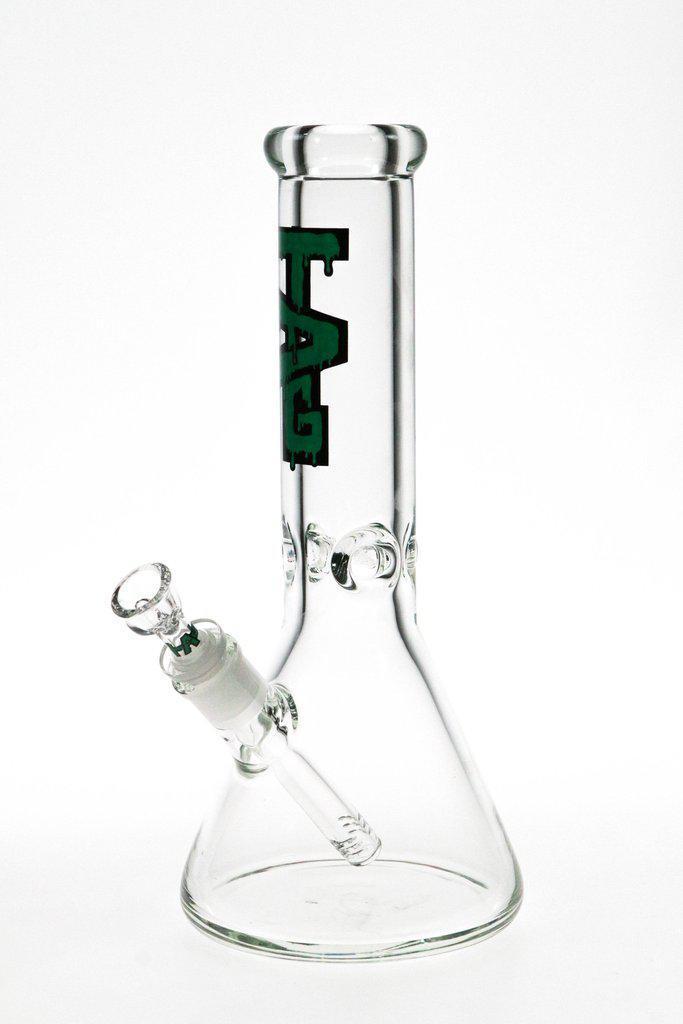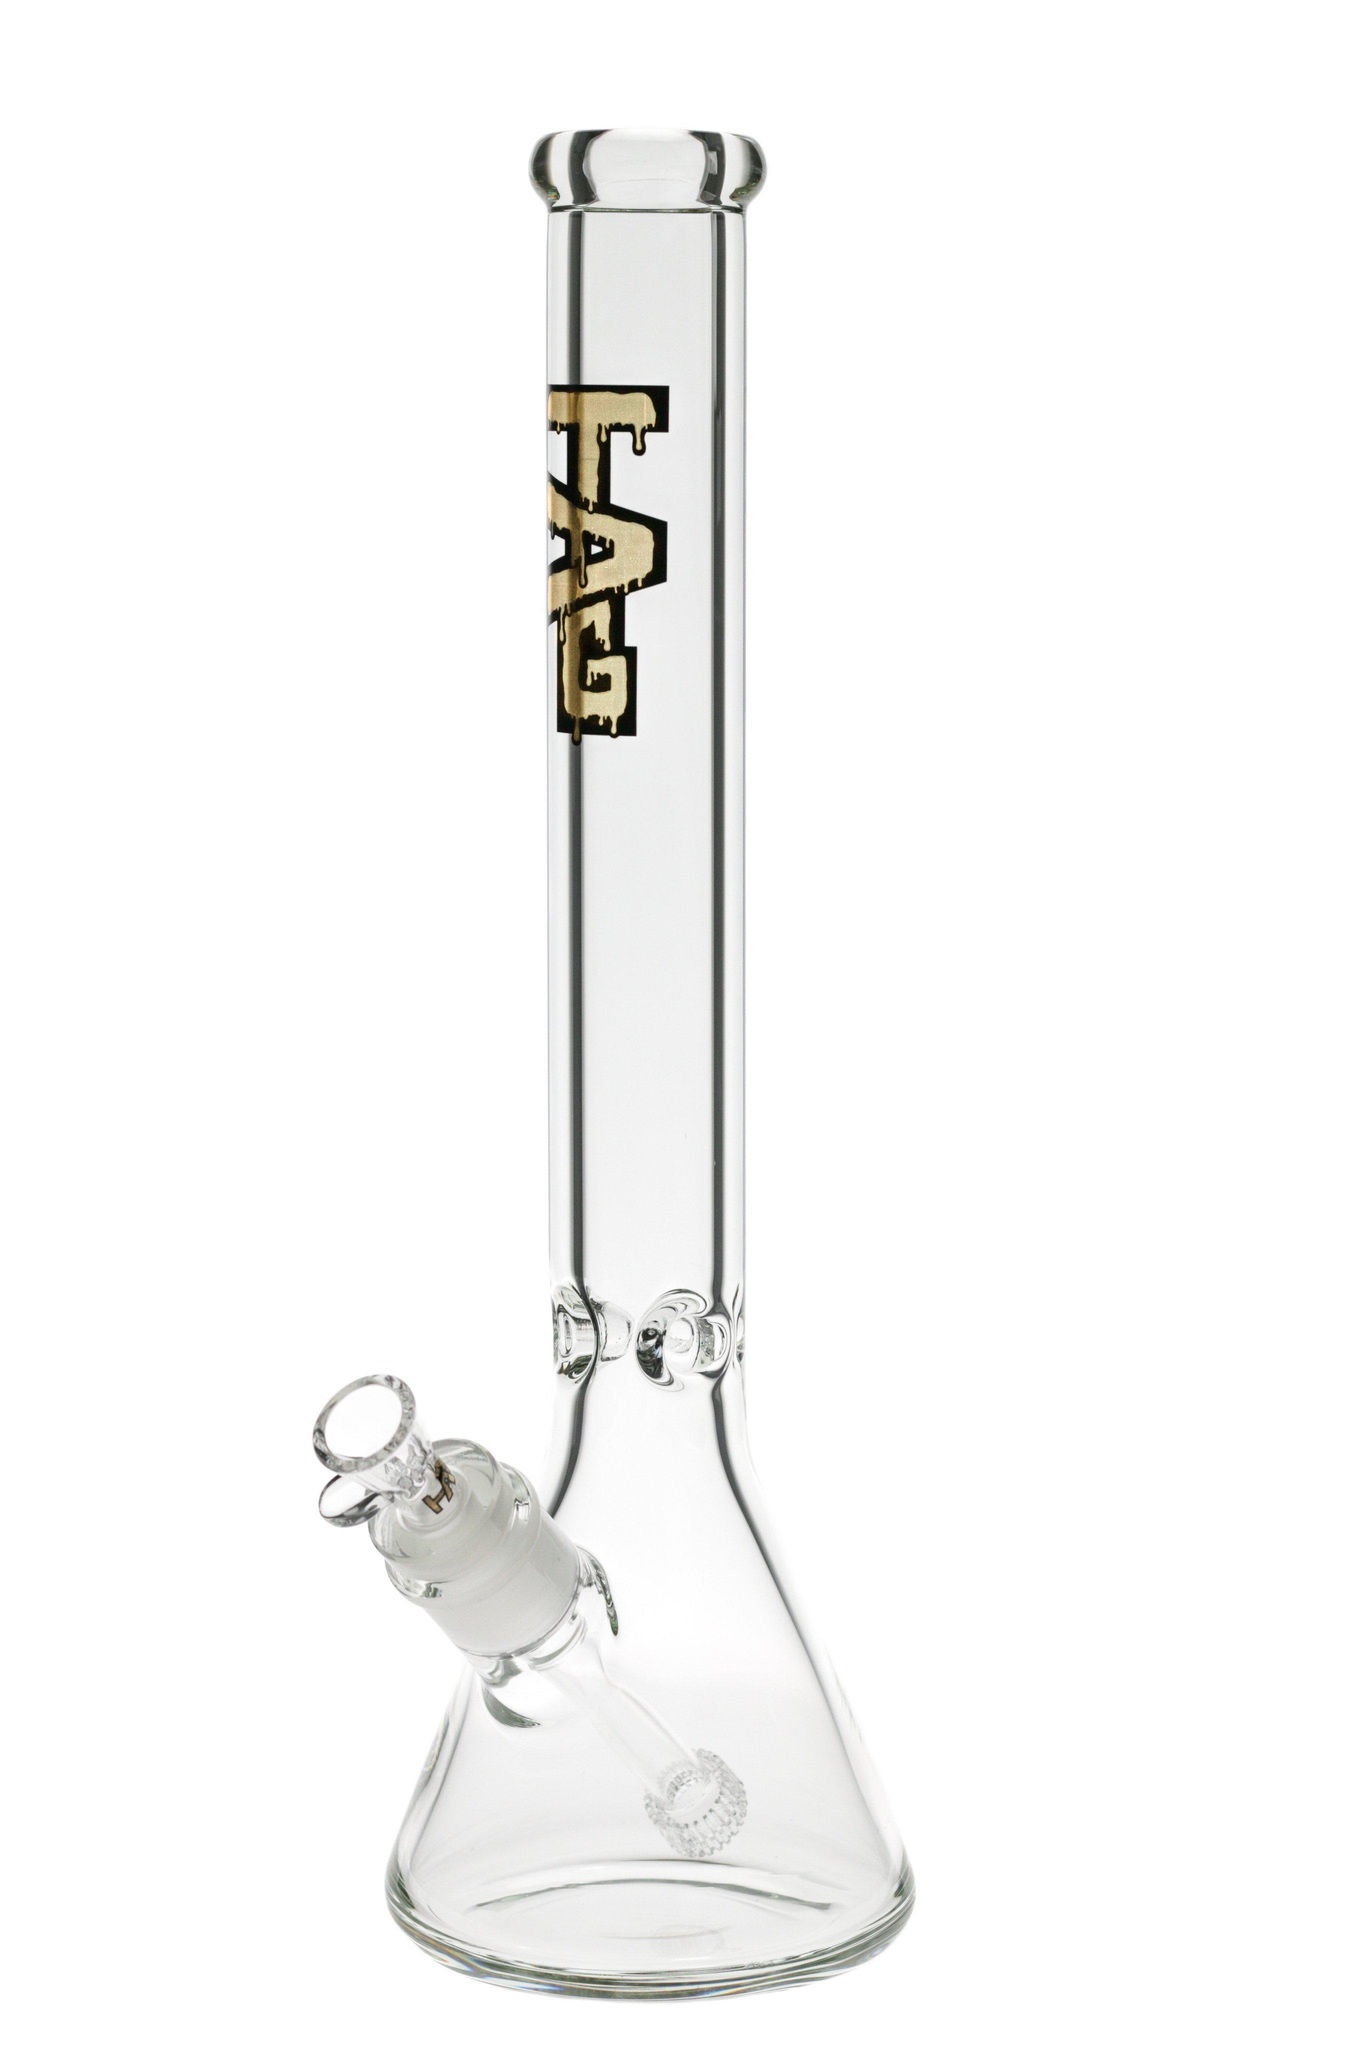The first image is the image on the left, the second image is the image on the right. For the images displayed, is the sentence "There are a total of two beaker bongs with the mouth pieces facing forward and left." factually correct? Answer yes or no. Yes. The first image is the image on the left, the second image is the image on the right. For the images displayed, is the sentence "The bowls of both bongs face the same direction." factually correct? Answer yes or no. Yes. 